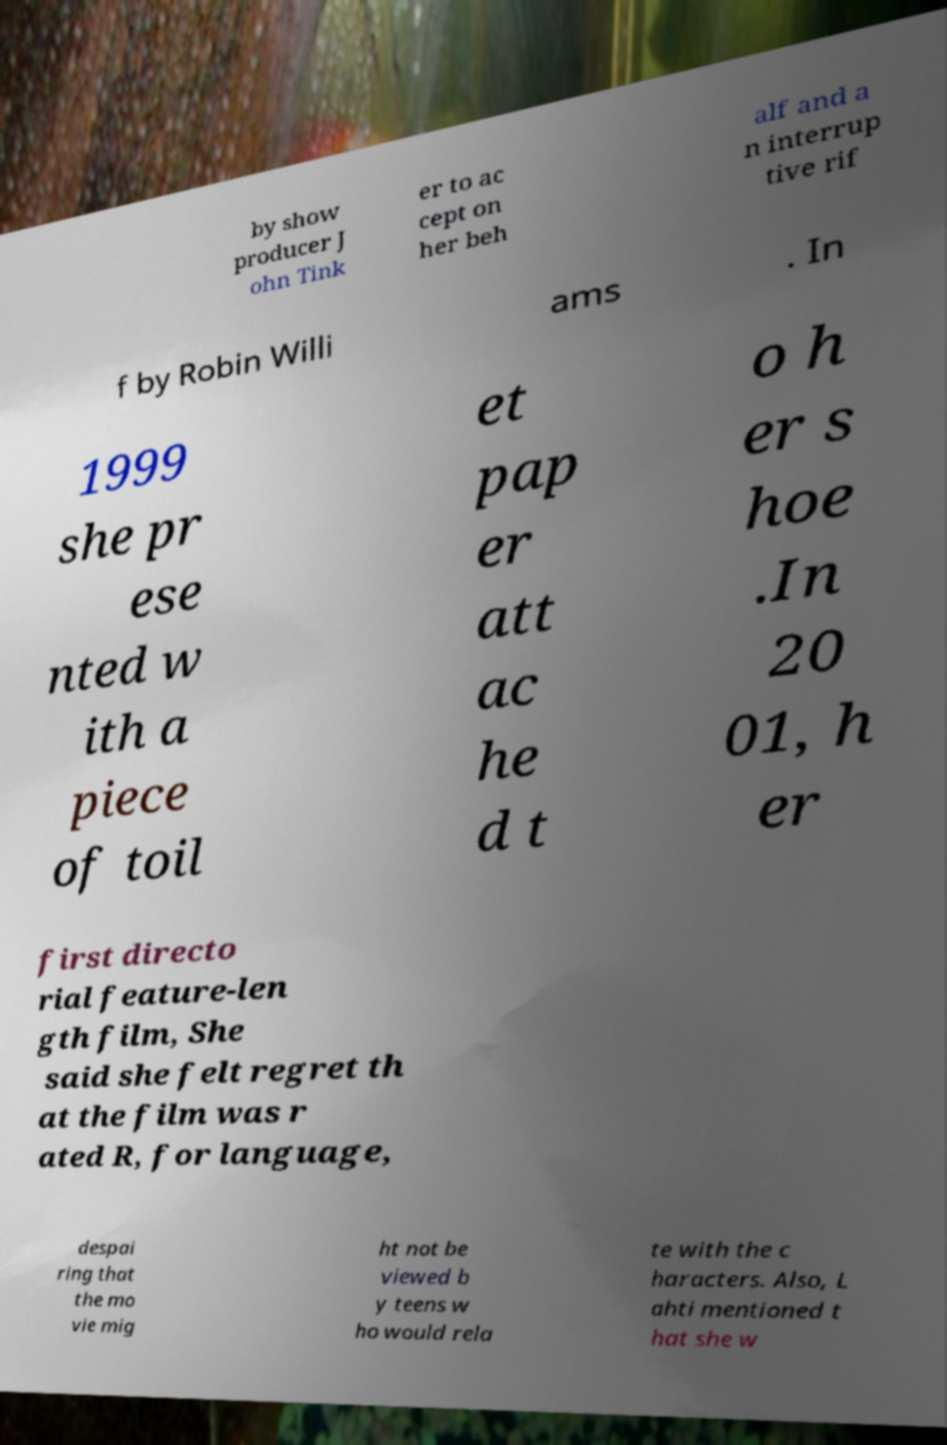I need the written content from this picture converted into text. Can you do that? by show producer J ohn Tink er to ac cept on her beh alf and a n interrup tive rif f by Robin Willi ams . In 1999 she pr ese nted w ith a piece of toil et pap er att ac he d t o h er s hoe .In 20 01, h er first directo rial feature-len gth film, She said she felt regret th at the film was r ated R, for language, despai ring that the mo vie mig ht not be viewed b y teens w ho would rela te with the c haracters. Also, L ahti mentioned t hat she w 